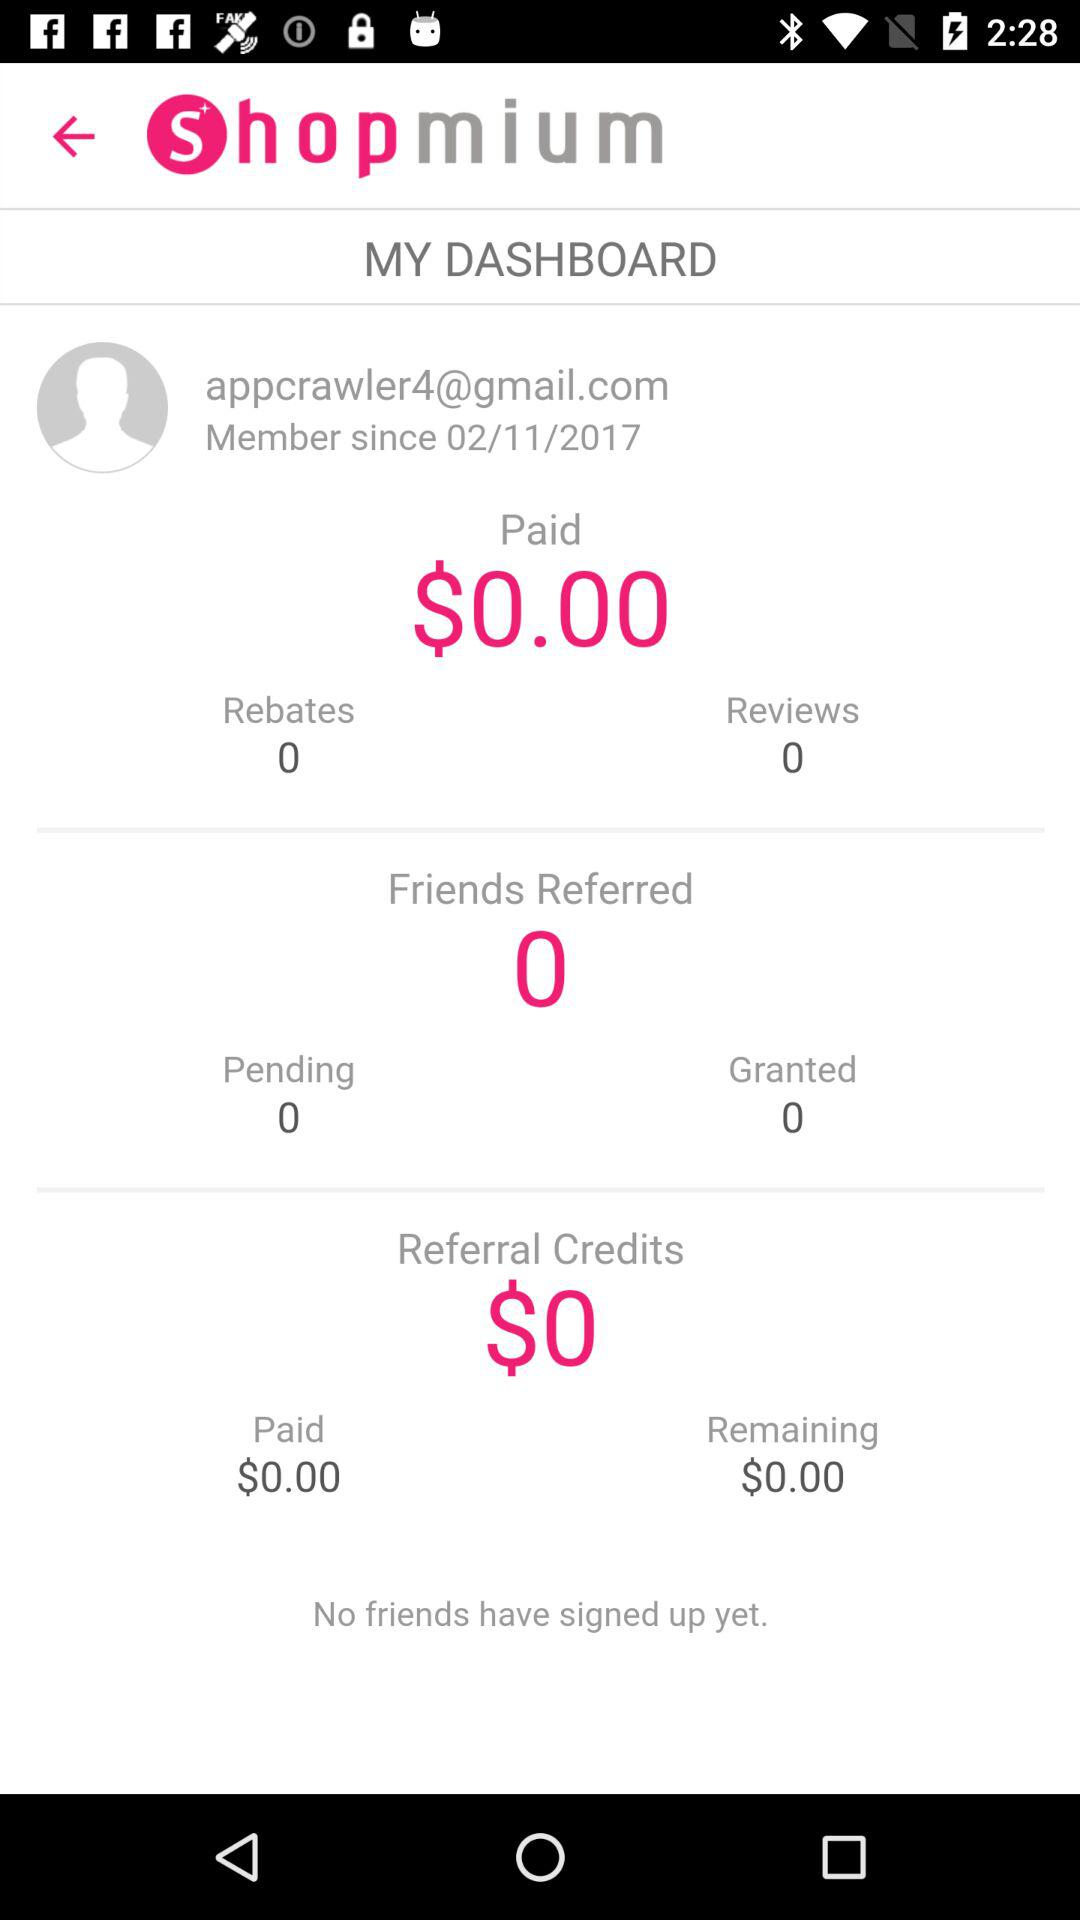What is the email address? The email address is appcrawler4@gmail.com. 